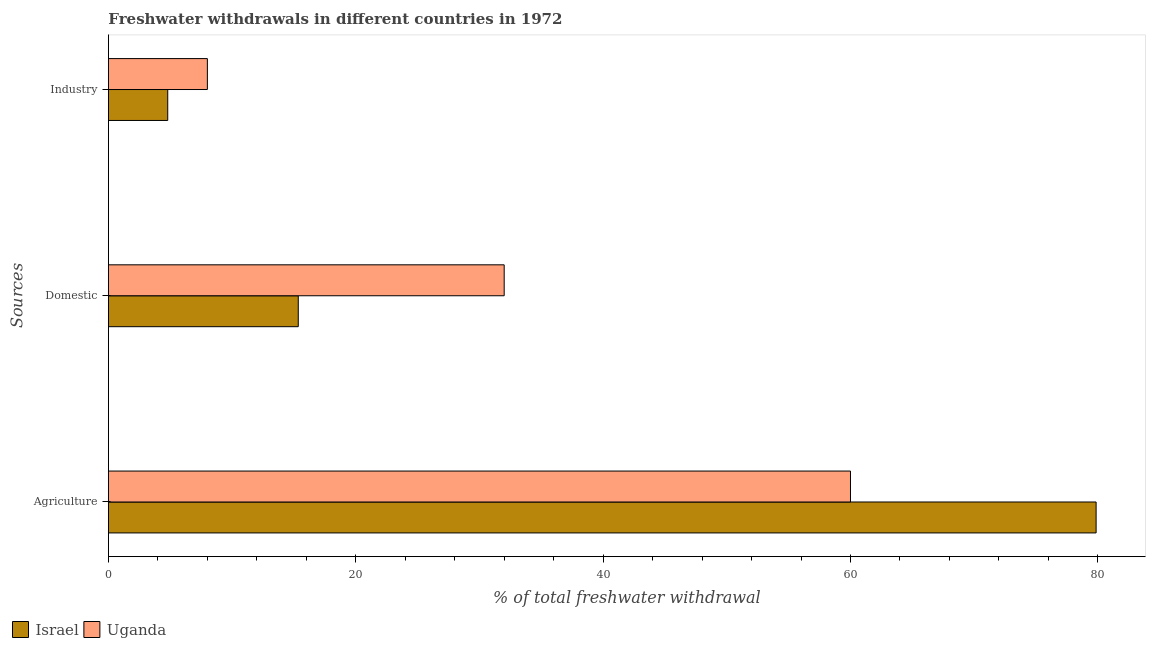Are the number of bars on each tick of the Y-axis equal?
Your response must be concise. Yes. What is the label of the 2nd group of bars from the top?
Your response must be concise. Domestic. Across all countries, what is the maximum percentage of freshwater withdrawal for domestic purposes?
Make the answer very short. 32. Across all countries, what is the minimum percentage of freshwater withdrawal for industry?
Keep it short and to the point. 4.79. In which country was the percentage of freshwater withdrawal for domestic purposes maximum?
Your response must be concise. Uganda. In which country was the percentage of freshwater withdrawal for agriculture minimum?
Offer a very short reply. Uganda. What is the total percentage of freshwater withdrawal for domestic purposes in the graph?
Make the answer very short. 47.35. What is the difference between the percentage of freshwater withdrawal for industry in Israel and that in Uganda?
Offer a very short reply. -3.21. What is the difference between the percentage of freshwater withdrawal for domestic purposes in Israel and the percentage of freshwater withdrawal for industry in Uganda?
Your answer should be compact. 7.35. What is the average percentage of freshwater withdrawal for agriculture per country?
Offer a terse response. 69.93. What is the difference between the percentage of freshwater withdrawal for domestic purposes and percentage of freshwater withdrawal for agriculture in Uganda?
Keep it short and to the point. -28. What is the ratio of the percentage of freshwater withdrawal for industry in Uganda to that in Israel?
Offer a very short reply. 1.67. Is the difference between the percentage of freshwater withdrawal for industry in Israel and Uganda greater than the difference between the percentage of freshwater withdrawal for agriculture in Israel and Uganda?
Make the answer very short. No. What is the difference between the highest and the second highest percentage of freshwater withdrawal for domestic purposes?
Provide a short and direct response. 16.65. What is the difference between the highest and the lowest percentage of freshwater withdrawal for domestic purposes?
Your response must be concise. 16.65. In how many countries, is the percentage of freshwater withdrawal for domestic purposes greater than the average percentage of freshwater withdrawal for domestic purposes taken over all countries?
Offer a terse response. 1. Is the sum of the percentage of freshwater withdrawal for agriculture in Israel and Uganda greater than the maximum percentage of freshwater withdrawal for industry across all countries?
Keep it short and to the point. Yes. What does the 2nd bar from the top in Domestic represents?
Ensure brevity in your answer.  Israel. What does the 1st bar from the bottom in Agriculture represents?
Your answer should be compact. Israel. How many bars are there?
Your answer should be very brief. 6. How many countries are there in the graph?
Ensure brevity in your answer.  2. What is the difference between two consecutive major ticks on the X-axis?
Give a very brief answer. 20. Does the graph contain grids?
Provide a succinct answer. No. What is the title of the graph?
Your answer should be compact. Freshwater withdrawals in different countries in 1972. Does "Europe(developing only)" appear as one of the legend labels in the graph?
Make the answer very short. No. What is the label or title of the X-axis?
Provide a short and direct response. % of total freshwater withdrawal. What is the label or title of the Y-axis?
Make the answer very short. Sources. What is the % of total freshwater withdrawal of Israel in Agriculture?
Make the answer very short. 79.86. What is the % of total freshwater withdrawal in Israel in Domestic?
Provide a succinct answer. 15.35. What is the % of total freshwater withdrawal of Uganda in Domestic?
Your response must be concise. 32. What is the % of total freshwater withdrawal of Israel in Industry?
Give a very brief answer. 4.79. Across all Sources, what is the maximum % of total freshwater withdrawal of Israel?
Offer a terse response. 79.86. Across all Sources, what is the minimum % of total freshwater withdrawal of Israel?
Give a very brief answer. 4.79. Across all Sources, what is the minimum % of total freshwater withdrawal of Uganda?
Give a very brief answer. 8. What is the total % of total freshwater withdrawal in Israel in the graph?
Make the answer very short. 100. What is the difference between the % of total freshwater withdrawal of Israel in Agriculture and that in Domestic?
Offer a very short reply. 64.51. What is the difference between the % of total freshwater withdrawal in Israel in Agriculture and that in Industry?
Offer a terse response. 75.06. What is the difference between the % of total freshwater withdrawal of Uganda in Agriculture and that in Industry?
Offer a very short reply. 52. What is the difference between the % of total freshwater withdrawal of Israel in Domestic and that in Industry?
Provide a short and direct response. 10.55. What is the difference between the % of total freshwater withdrawal of Uganda in Domestic and that in Industry?
Ensure brevity in your answer.  24. What is the difference between the % of total freshwater withdrawal in Israel in Agriculture and the % of total freshwater withdrawal in Uganda in Domestic?
Offer a terse response. 47.86. What is the difference between the % of total freshwater withdrawal in Israel in Agriculture and the % of total freshwater withdrawal in Uganda in Industry?
Your answer should be compact. 71.86. What is the difference between the % of total freshwater withdrawal in Israel in Domestic and the % of total freshwater withdrawal in Uganda in Industry?
Keep it short and to the point. 7.35. What is the average % of total freshwater withdrawal in Israel per Sources?
Offer a terse response. 33.34. What is the average % of total freshwater withdrawal of Uganda per Sources?
Make the answer very short. 33.33. What is the difference between the % of total freshwater withdrawal in Israel and % of total freshwater withdrawal in Uganda in Agriculture?
Offer a terse response. 19.86. What is the difference between the % of total freshwater withdrawal of Israel and % of total freshwater withdrawal of Uganda in Domestic?
Your answer should be very brief. -16.65. What is the difference between the % of total freshwater withdrawal of Israel and % of total freshwater withdrawal of Uganda in Industry?
Offer a very short reply. -3.21. What is the ratio of the % of total freshwater withdrawal in Israel in Agriculture to that in Domestic?
Your answer should be very brief. 5.2. What is the ratio of the % of total freshwater withdrawal of Uganda in Agriculture to that in Domestic?
Provide a short and direct response. 1.88. What is the ratio of the % of total freshwater withdrawal in Israel in Agriculture to that in Industry?
Make the answer very short. 16.65. What is the ratio of the % of total freshwater withdrawal in Israel in Domestic to that in Industry?
Give a very brief answer. 3.2. What is the difference between the highest and the second highest % of total freshwater withdrawal of Israel?
Provide a succinct answer. 64.51. What is the difference between the highest and the second highest % of total freshwater withdrawal of Uganda?
Provide a succinct answer. 28. What is the difference between the highest and the lowest % of total freshwater withdrawal of Israel?
Keep it short and to the point. 75.06. What is the difference between the highest and the lowest % of total freshwater withdrawal in Uganda?
Offer a terse response. 52. 